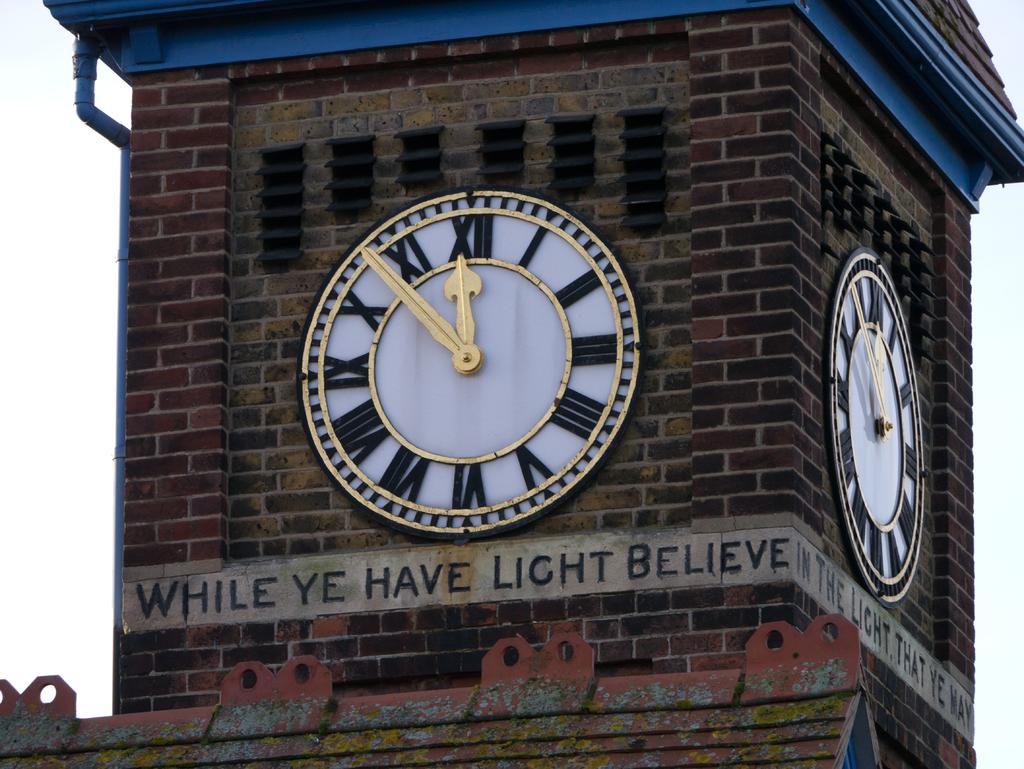What is the motto for this clock tower?
Your response must be concise. While ye have light believe. What time does the clock have?
Offer a very short reply. 11:54. 